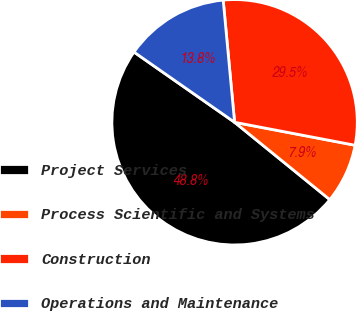Convert chart. <chart><loc_0><loc_0><loc_500><loc_500><pie_chart><fcel>Project Services<fcel>Process Scientific and Systems<fcel>Construction<fcel>Operations and Maintenance<nl><fcel>48.84%<fcel>7.86%<fcel>29.48%<fcel>13.82%<nl></chart> 